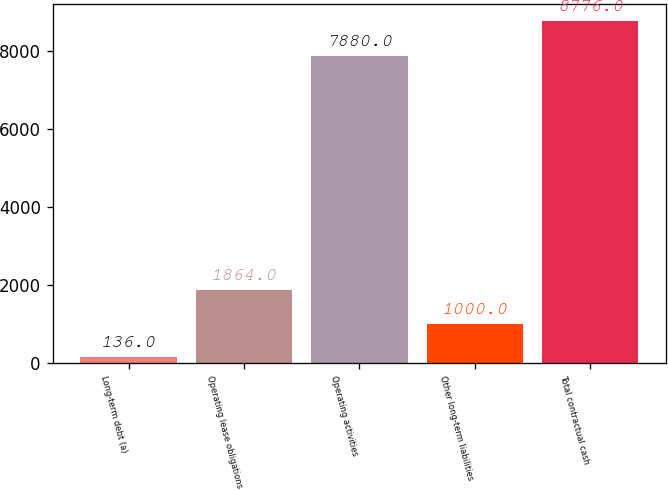Convert chart to OTSL. <chart><loc_0><loc_0><loc_500><loc_500><bar_chart><fcel>Long-term debt (a)<fcel>Operating lease obligations<fcel>Operating activities<fcel>Other long-term liabilities<fcel>Total contractual cash<nl><fcel>136<fcel>1864<fcel>7880<fcel>1000<fcel>8776<nl></chart> 